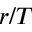Convert formula to latex. <formula><loc_0><loc_0><loc_500><loc_500>r / T</formula> 